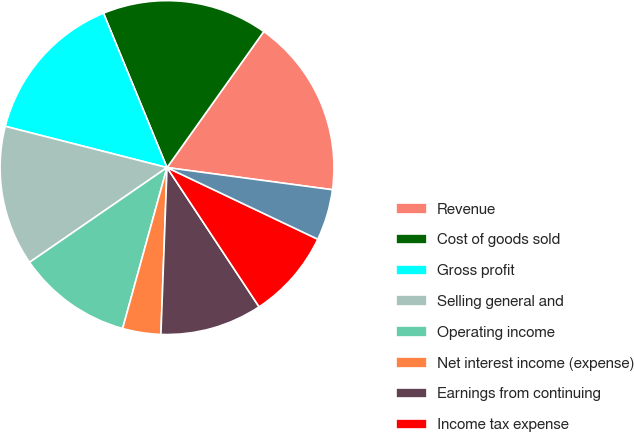Convert chart to OTSL. <chart><loc_0><loc_0><loc_500><loc_500><pie_chart><fcel>Revenue<fcel>Cost of goods sold<fcel>Gross profit<fcel>Selling general and<fcel>Operating income<fcel>Net interest income (expense)<fcel>Earnings from continuing<fcel>Income tax expense<fcel>Net earnings<nl><fcel>17.28%<fcel>16.05%<fcel>14.81%<fcel>13.58%<fcel>11.11%<fcel>3.7%<fcel>9.88%<fcel>8.64%<fcel>4.94%<nl></chart> 